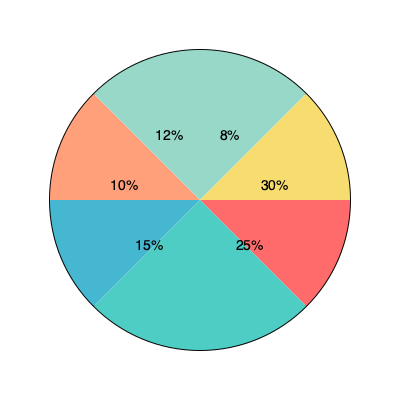Based on the pie chart showing market share of various pharmaceutical companies, what percentage of the market is controlled by the top three companies combined? To find the percentage of the market controlled by the top three companies, we need to:

1. Identify the top three companies by market share:
   - Company 1: 30%
   - Company 2: 25%
   - Company 3: 15%

2. Add the market shares of these three companies:
   $30\% + 25\% + 15\% = 70\%$

Therefore, the top three companies combined control 70% of the market.

This information is crucial for a digital marketing manager in a pharmaceutical company to understand the competitive landscape and develop effective marketing strategies. It helps in identifying the major players, potential collaborations, and areas for market growth.
Answer: 70% 